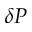Convert formula to latex. <formula><loc_0><loc_0><loc_500><loc_500>\delta P</formula> 